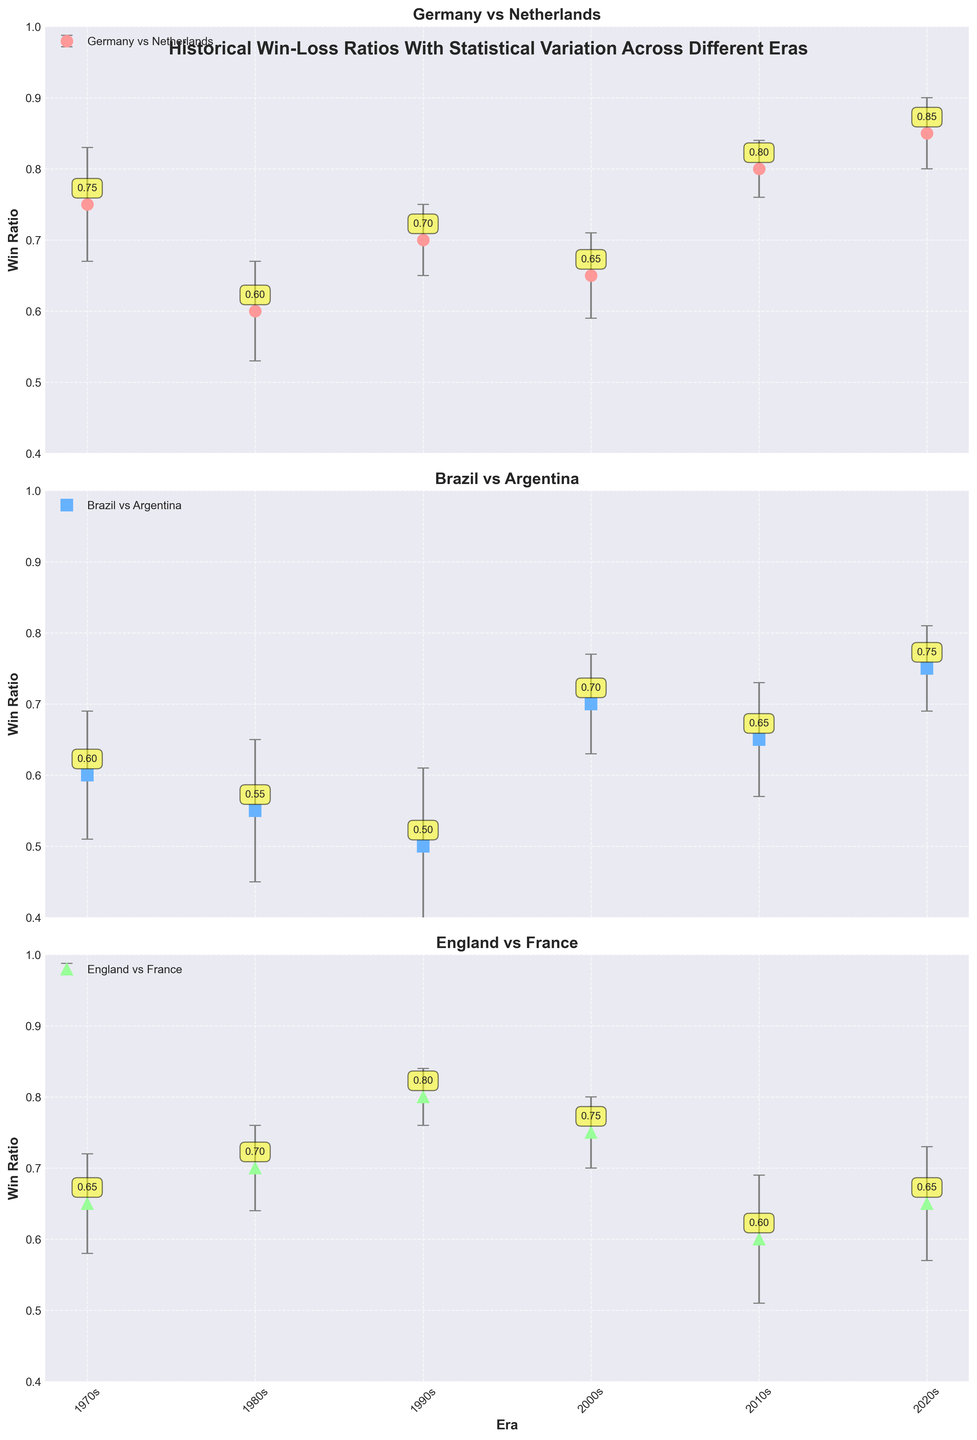What are the win ratios for Germany against the Netherlands in the 1970s and 2020s? To find the win ratios for Germany against the Netherlands in the 1970s and 2020s, look at the Germany subplot and identify the markers for these eras. The 1970s win ratio is at the first marker, and the 2020s win ratio is at the last marker, respectively.
Answer: 0.75, 0.85 How does Brazil's win ratio against Argentina in the 1980s compare to the 2010s? To compare the win ratios for these two periods, locate the markers for the 1980s and the 2010s in Brazil's subplot. Note the values and compare them directly. Brazil's win ratio in the 1980s is 0.55, and in the 2010s it is 0.65.
Answer: 0.55 (1980s), 0.65 (2010s) Between Germany and Brazil, which country had a higher win ratio against its opponent in the 2000s? First, locate the win ratios for Germany (against Netherlands) and Brazil (against Argentina) in the 2000s in their respective subplots. Compare the values directly; Germany has a win ratio of 0.65, and Brazil has a win ratio of 0.70.
Answer: Brazil What was the trend in England's win ratio against France from the 1970s to the 2020s? To identify the trend, trace England's win ratios across the eras from the 1970s to the 2020s in their subplot. The ratios are: 0.65 (1970s), 0.70 (1980s), 0.80 (1990s), 0.75 (2000s), 0.60 (2010s), and 0.65 (2020s). The trend shows fluctuations with an initial increase, then a drop, and a plateau.
Answer: Fluctuating Which era has the smallest error margin for Germany's win ratio against the Netherlands? To determine the smallest error margin for Germany's win ratios, check the error bars on Germany's subplot across all eras. The smallest error margin is observed in the 1990s.
Answer: 1990s What is the overall pattern of Brazil's win ratio against Argentina? To identify the overall pattern for Brazil's win ratios, follow the markers across different eras in Brazil's subplot. The ratios are: 0.60 (1970s), 0.55 (1980s), 0.50 (1990s), 0.70 (2000s), 0.65 (2010s), 0.75 (2020s). The pattern shows variability with an initial decline followed by an increase in later years.
Answer: Variable with an increase in later years Which country showed the highest win ratio in any era, and in which era was it? To find the highest win ratio, compare the peak values in each country's subplot. Germany has the highest win ratio of 0.85 against the Netherlands in the 2020s.
Answer: Germany in the 2020s What is the average win ratio for England against France across all eras? To calculate the average win ratio, sum England's win ratios from each era and divide by the number of eras: (0.65 + 0.70 + 0.80 + 0.75 + 0.60 + 0.65) / 6 = 4.15 / 6.
Answer: 0.69 